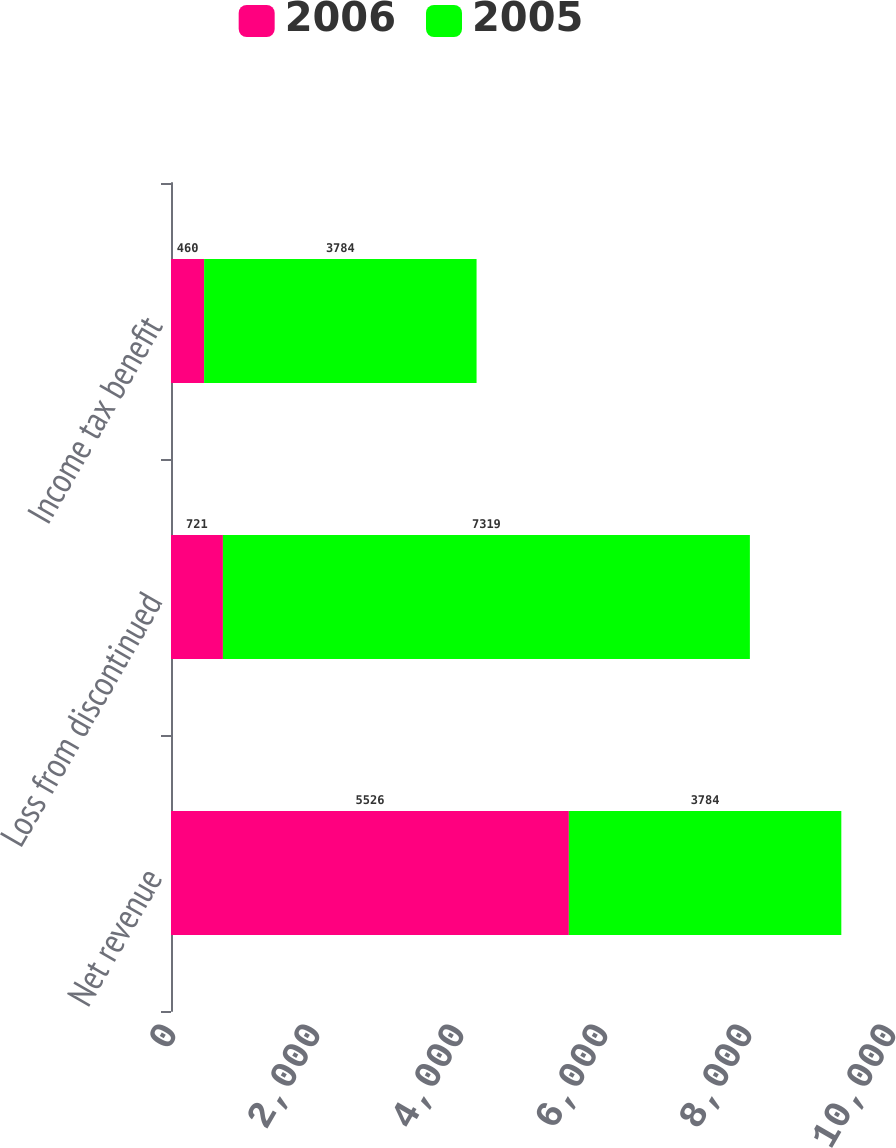Convert chart to OTSL. <chart><loc_0><loc_0><loc_500><loc_500><stacked_bar_chart><ecel><fcel>Net revenue<fcel>Loss from discontinued<fcel>Income tax benefit<nl><fcel>2006<fcel>5526<fcel>721<fcel>460<nl><fcel>2005<fcel>3784<fcel>7319<fcel>3784<nl></chart> 